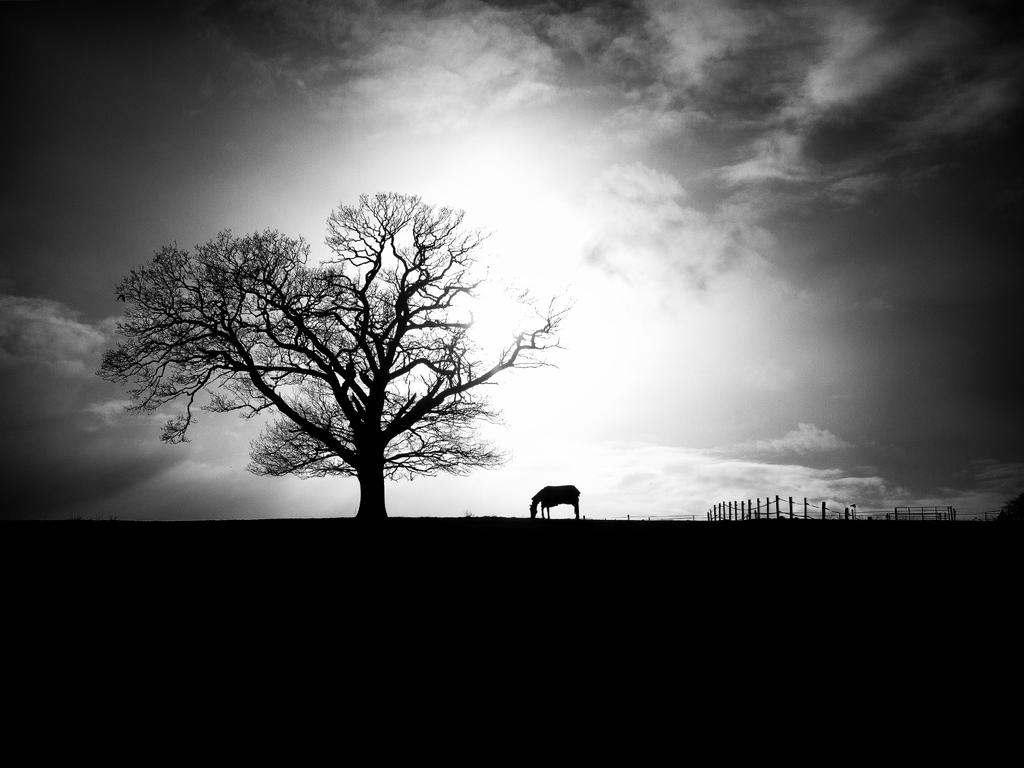What color is present at the bottom of the image? There is a dark color at the bottom of the image. What can be found in the middle of the image? There is a tree and a horse in the middle of the image. What is separating the tree and the horse in the image? There is a fence in the middle of the image. What is visible in the background of the image? The background of the image is covered by the sky. Can you determine the time of day the image was taken? The image may have been taken during the night, as indicated by the dark color at the bottom. What type of account is being discussed in the image? There is no account being discussed in the image; it features a tree, a horse, and a fence in the middle of the image. What type of soup is being served in the image? There is no soup present in the image; it features a tree, a horse, and a fence in the middle of the image. 